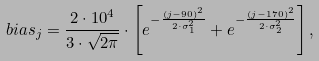<formula> <loc_0><loc_0><loc_500><loc_500>b i a s _ { j } = \frac { 2 \cdot 1 0 ^ { 4 } } { 3 \cdot \sqrt { 2 \pi } } \cdot \left [ e ^ { - \frac { ( j - 9 0 ) ^ { 2 } } { 2 \cdot \sigma _ { 1 } ^ { 2 } } } + e ^ { - \frac { ( j - 1 7 0 ) ^ { 2 } } { 2 \cdot \sigma _ { 2 } ^ { 2 } } } \right ] ,</formula> 